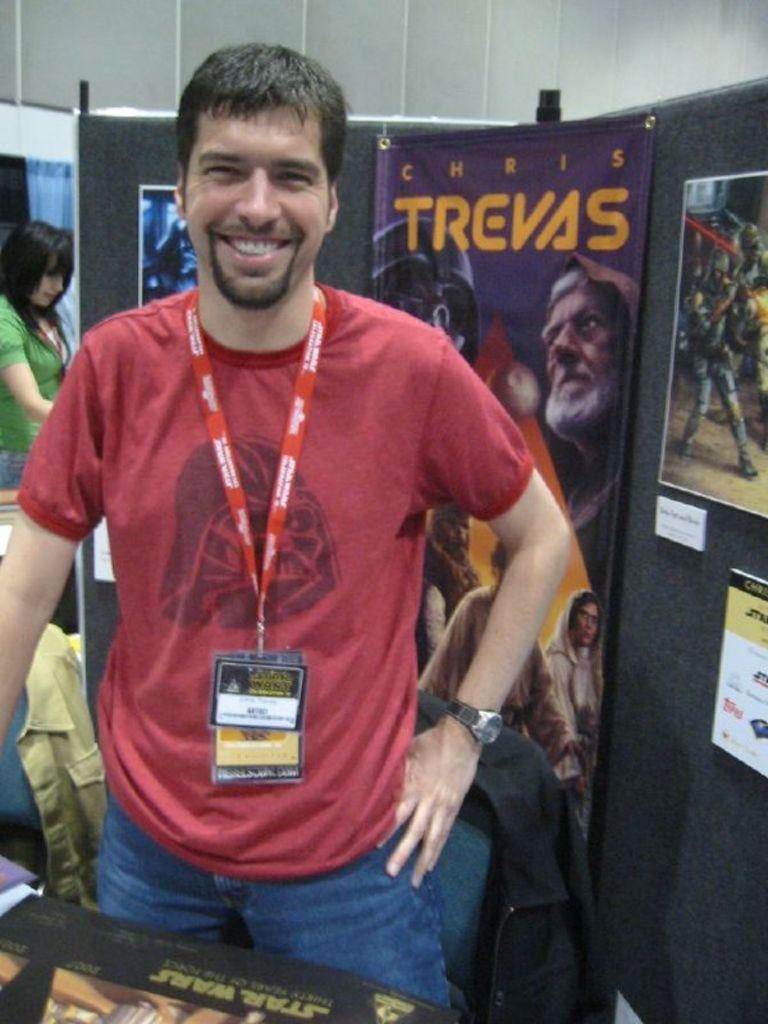Provide a one-sentence caption for the provided image. A smiling mans wearing red tee is standing in front of the purple Chris Trevas poster. 